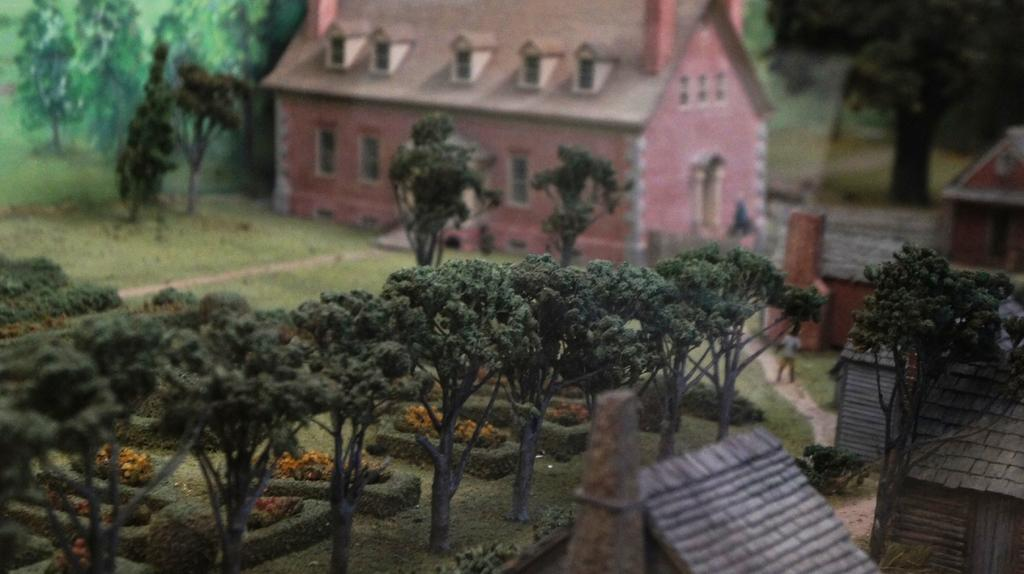What type of structure is visible in the image? There is a house in the image. What is located in front of the house? There are trees in front of the house. Are there any other houses visible in the image? Yes, there are houses on the right side of the image. Can you describe the person in the image? There is a person standing on the road. What type of drink is the person holding in the image? There is no drink visible in the image; the person is standing on the road without any visible objects in their hands. 